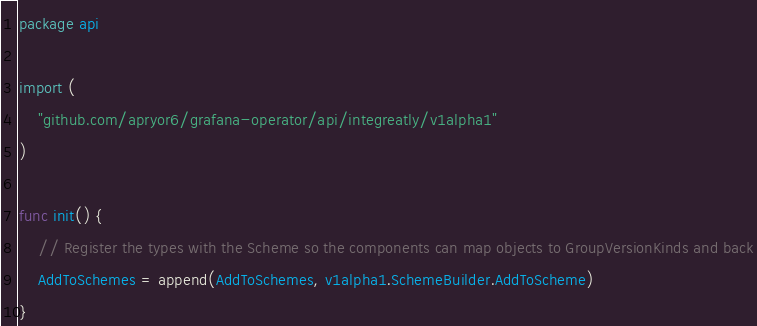<code> <loc_0><loc_0><loc_500><loc_500><_Go_>package api

import (
	"github.com/apryor6/grafana-operator/api/integreatly/v1alpha1"
)

func init() {
	// Register the types with the Scheme so the components can map objects to GroupVersionKinds and back
	AddToSchemes = append(AddToSchemes, v1alpha1.SchemeBuilder.AddToScheme)
}
</code> 